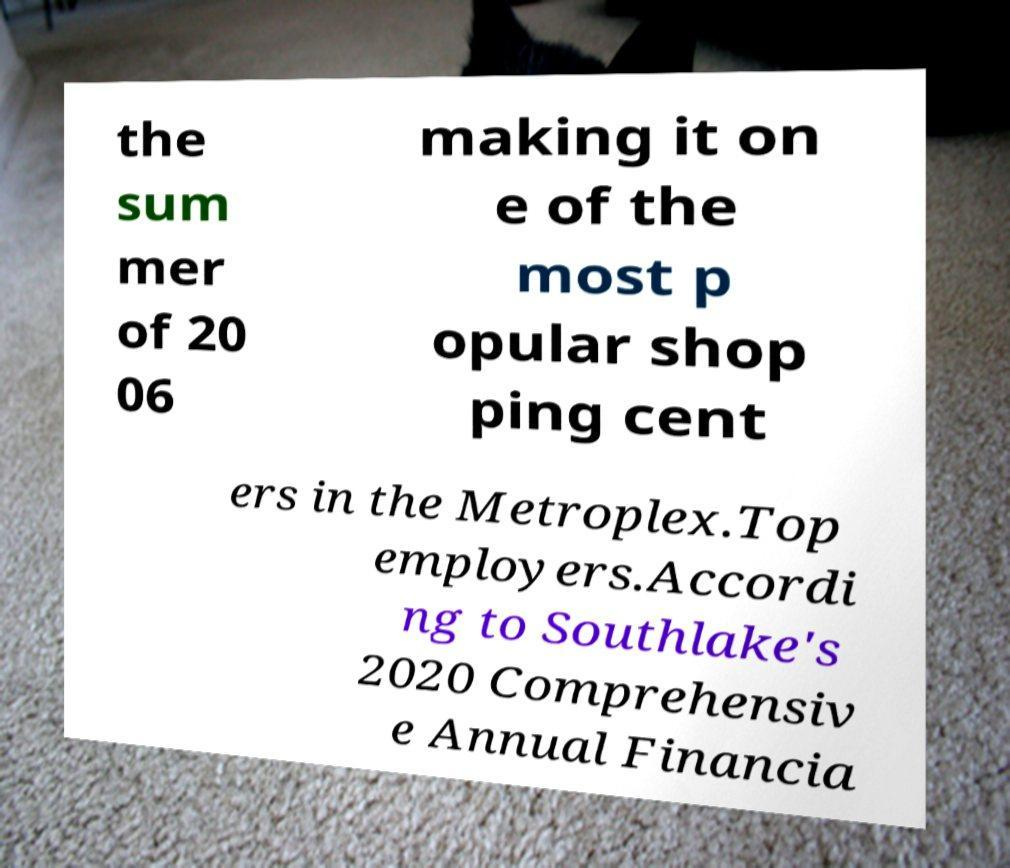For documentation purposes, I need the text within this image transcribed. Could you provide that? the sum mer of 20 06 making it on e of the most p opular shop ping cent ers in the Metroplex.Top employers.Accordi ng to Southlake's 2020 Comprehensiv e Annual Financia 